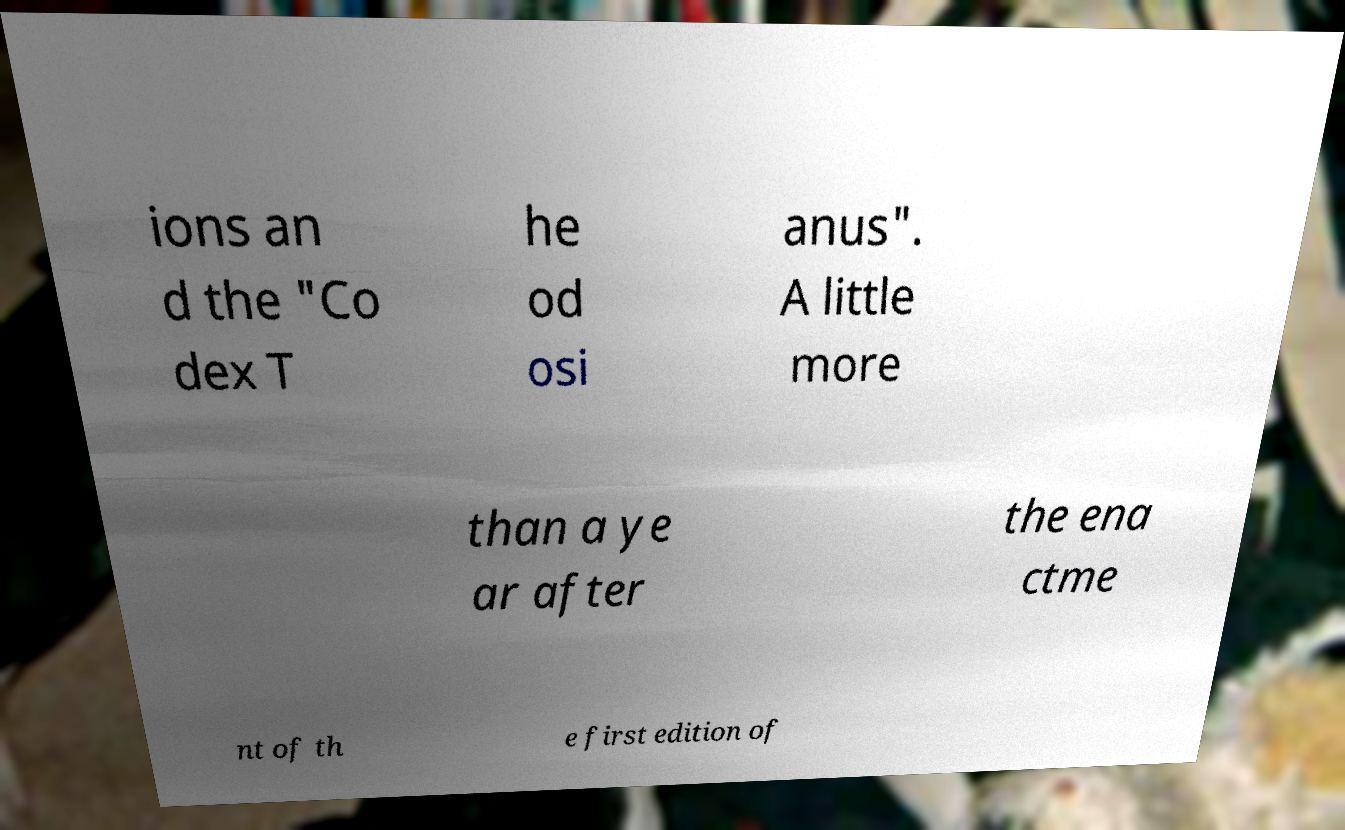Can you accurately transcribe the text from the provided image for me? ions an d the "Co dex T he od osi anus". A little more than a ye ar after the ena ctme nt of th e first edition of 